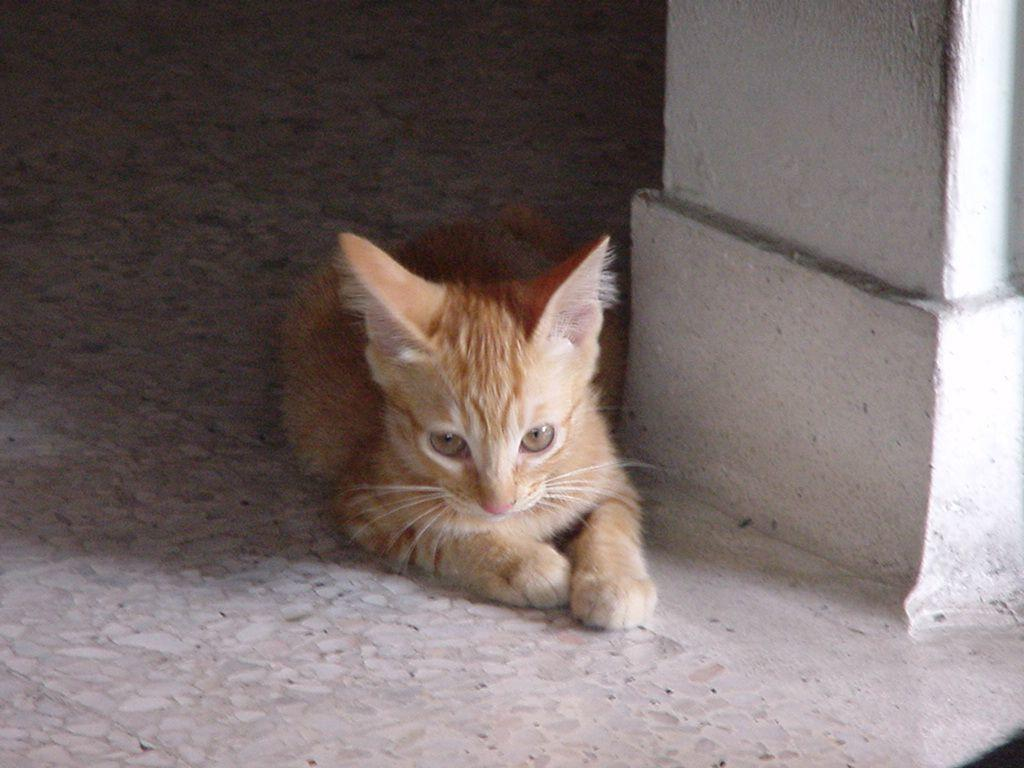What animal can be seen in the image? There is a cat in the image. Where is the cat located in the image? The cat is on the floor. What is visible on the right side of the image? There is a wall on the right side of the image. Where is the bat hanging in the image? There is no bat present in the image. 